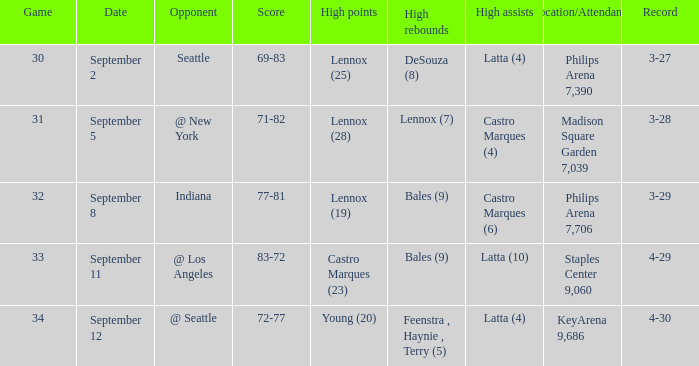Which Location/Attendance has High rebounds of lennox (7)? Madison Square Garden 7,039. 